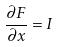Convert formula to latex. <formula><loc_0><loc_0><loc_500><loc_500>\frac { \partial F } { \partial x } = I</formula> 